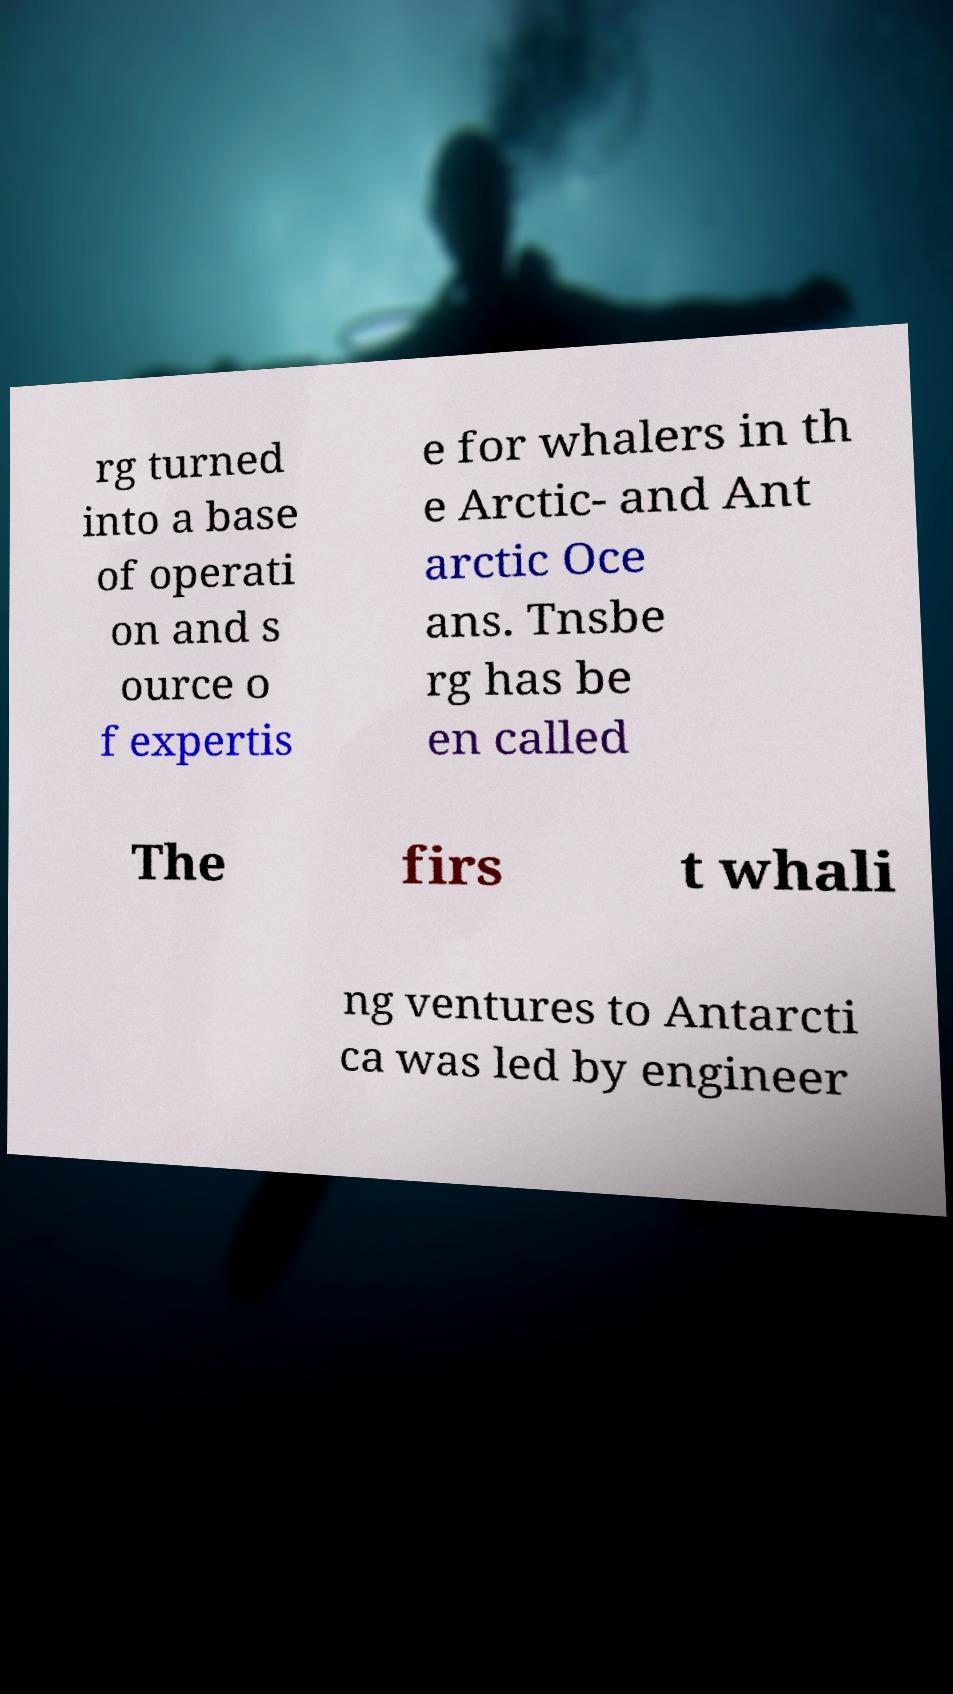For documentation purposes, I need the text within this image transcribed. Could you provide that? rg turned into a base of operati on and s ource o f expertis e for whalers in th e Arctic- and Ant arctic Oce ans. Tnsbe rg has be en called The firs t whali ng ventures to Antarcti ca was led by engineer 